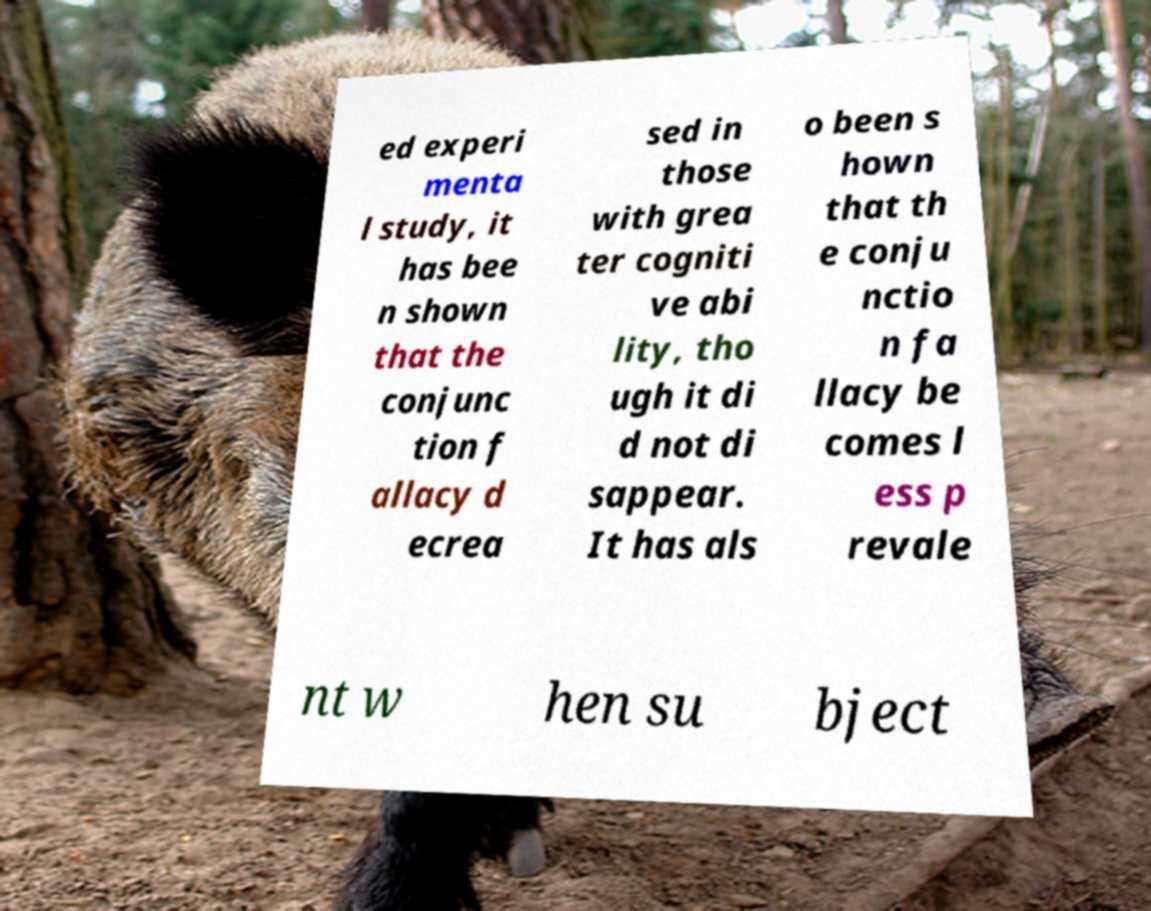Please read and relay the text visible in this image. What does it say? ed experi menta l study, it has bee n shown that the conjunc tion f allacy d ecrea sed in those with grea ter cogniti ve abi lity, tho ugh it di d not di sappear. It has als o been s hown that th e conju nctio n fa llacy be comes l ess p revale nt w hen su bject 